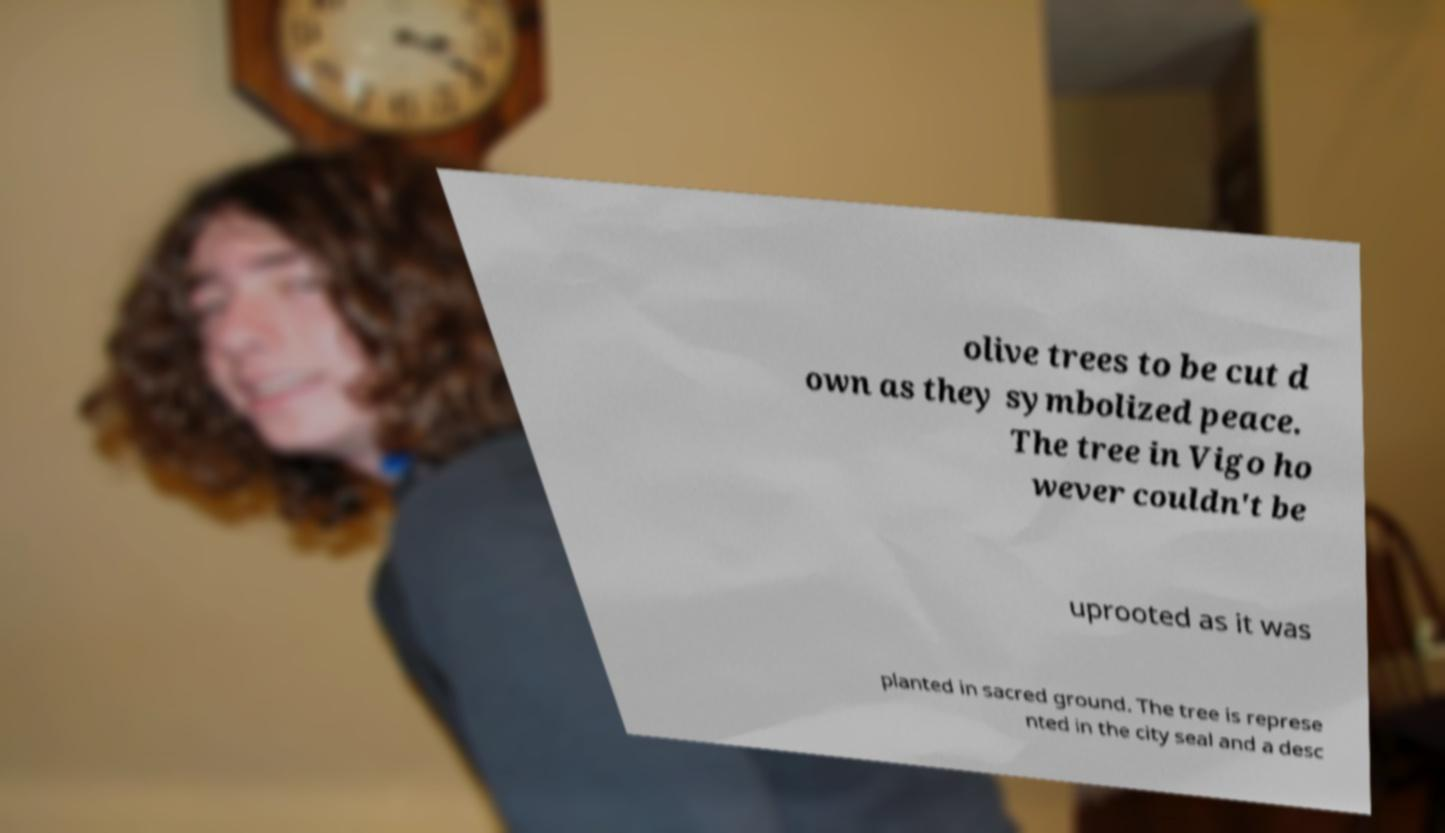For documentation purposes, I need the text within this image transcribed. Could you provide that? olive trees to be cut d own as they symbolized peace. The tree in Vigo ho wever couldn't be uprooted as it was planted in sacred ground. The tree is represe nted in the city seal and a desc 